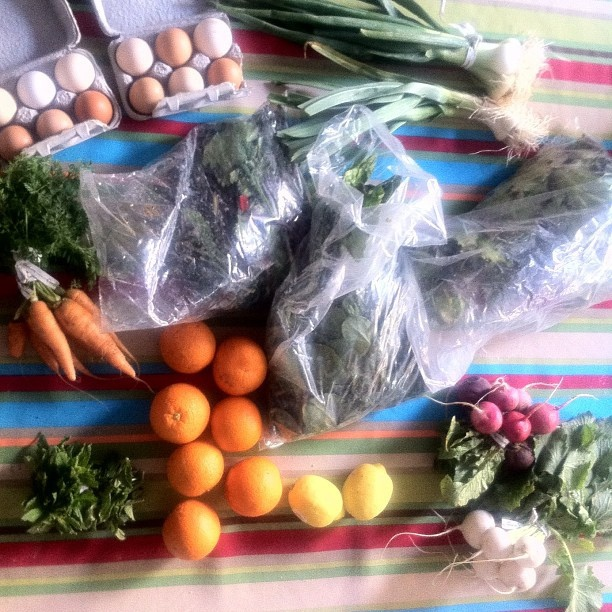Describe the objects in this image and their specific colors. I can see carrot in darkgray, maroon, salmon, black, and brown tones, orange in darkgray, red, gold, orange, and khaki tones, orange in darkgray, orange, gold, red, and maroon tones, orange in darkgray, orange, red, maroon, and gold tones, and orange in darkgray, red, brown, and maroon tones in this image. 